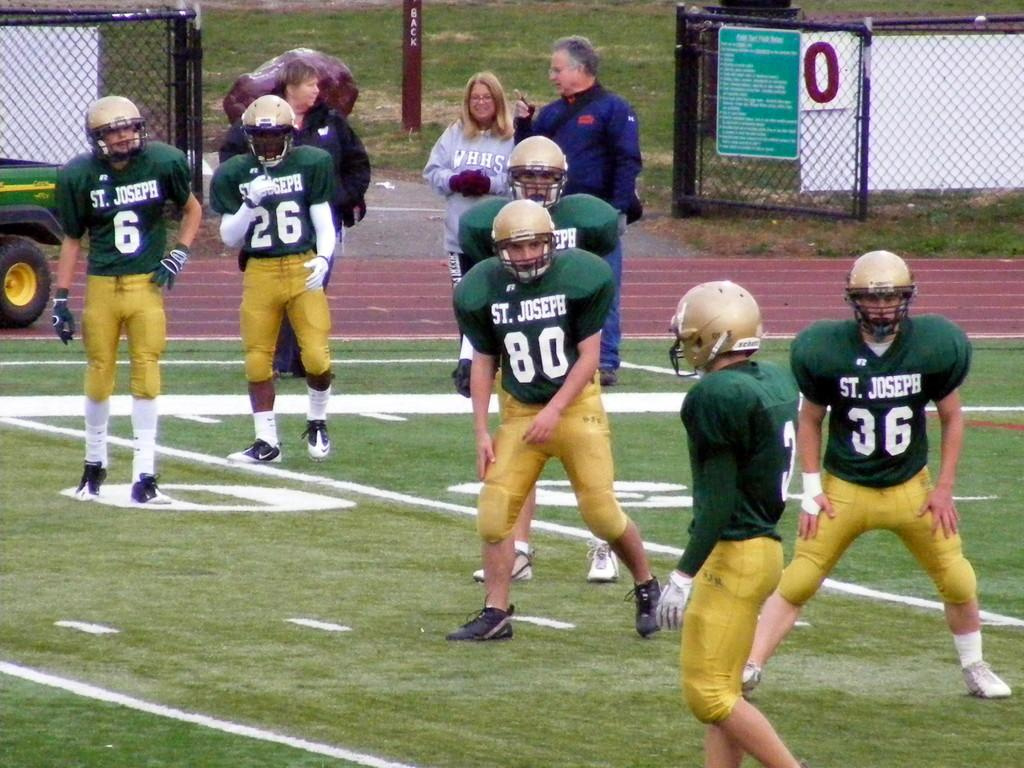How many people are in the image? There are people in the image, but the exact number is not specified. What are some people wearing in the image? Some people are wearing helmets in the image. What type of terrain is visible in the image? There is grass visible in the image. What is on the ground in the image? There is a vehicle on the ground in the image. What type of structure is present in the image? There is a gate in the image. What type of materials are present in the image? There are boards and meshes visible in the image. What type of natural element is present in the image? There is a rock in the image. What type of man-made structure is present in the image? There is a pole in the image. What type of yarn is being used to create the boys in the image? There are no boys present in the image, and no yarn is mentioned or visible. 